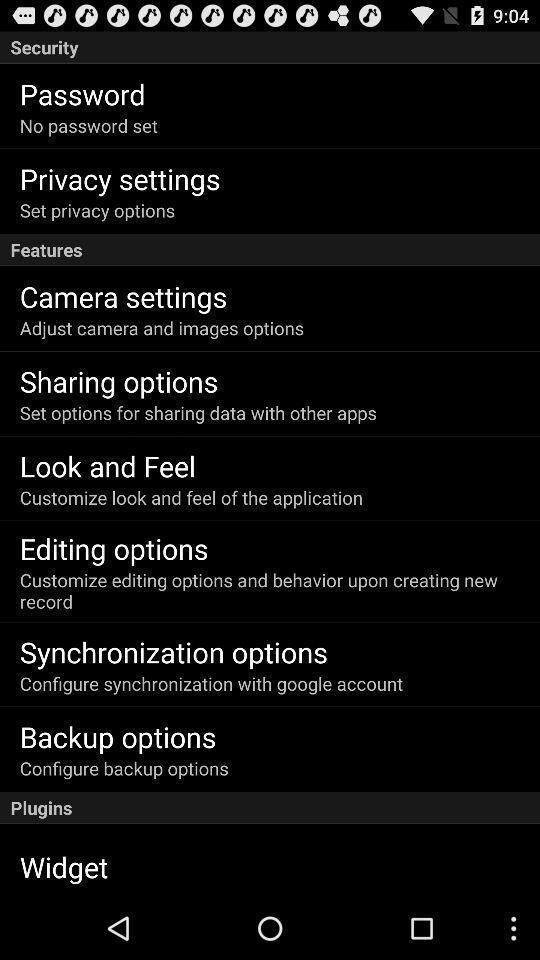Give me a summary of this screen capture. Privacy settings. 